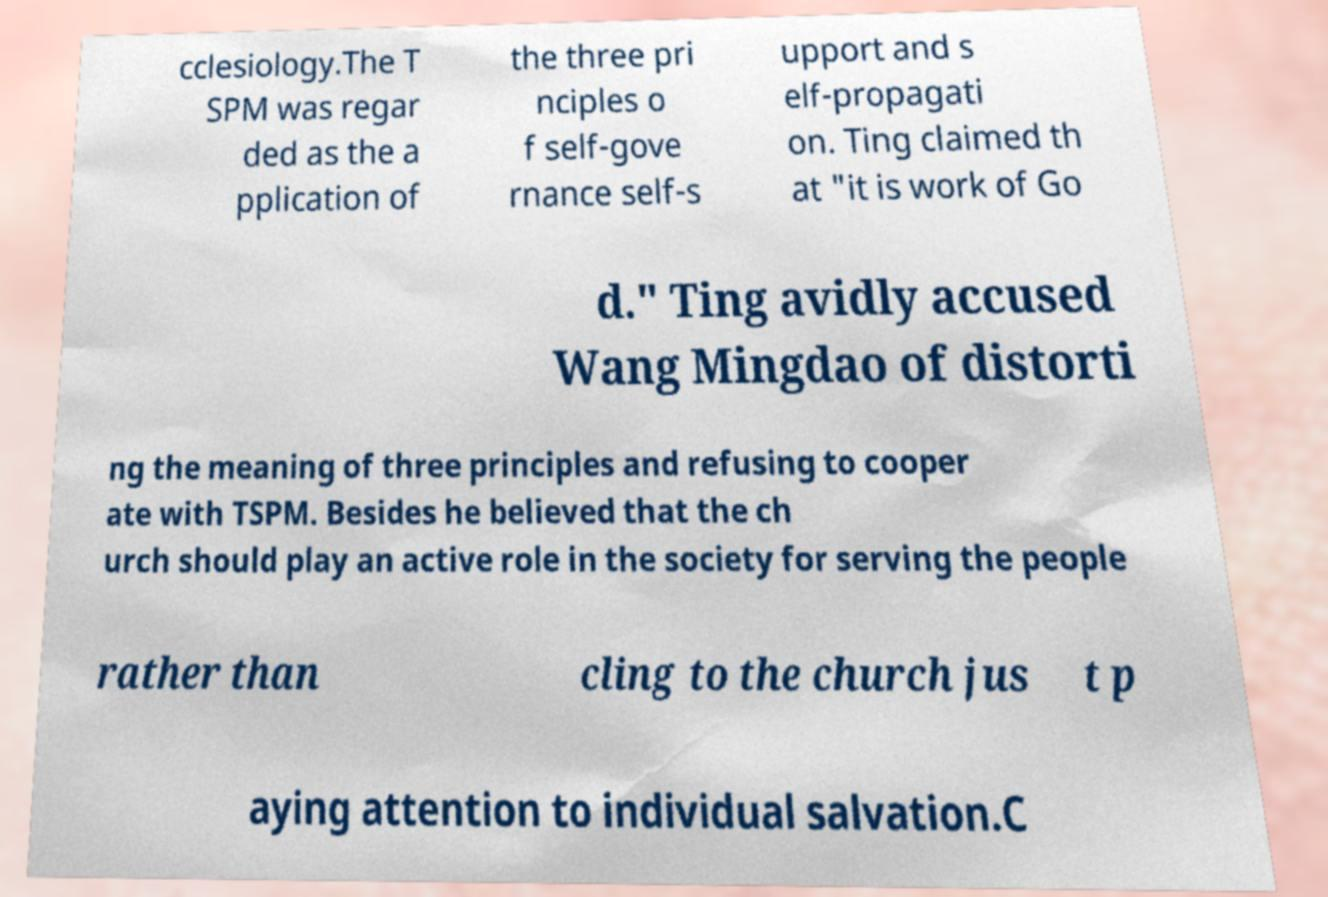For documentation purposes, I need the text within this image transcribed. Could you provide that? cclesiology.The T SPM was regar ded as the a pplication of the three pri nciples o f self-gove rnance self-s upport and s elf-propagati on. Ting claimed th at "it is work of Go d." Ting avidly accused Wang Mingdao of distorti ng the meaning of three principles and refusing to cooper ate with TSPM. Besides he believed that the ch urch should play an active role in the society for serving the people rather than cling to the church jus t p aying attention to individual salvation.C 